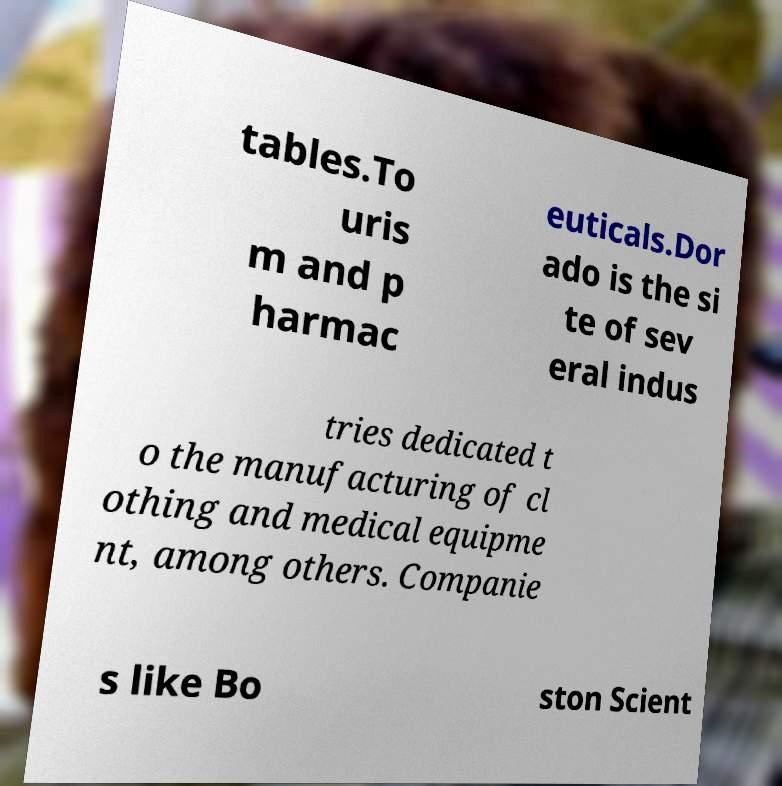There's text embedded in this image that I need extracted. Can you transcribe it verbatim? tables.To uris m and p harmac euticals.Dor ado is the si te of sev eral indus tries dedicated t o the manufacturing of cl othing and medical equipme nt, among others. Companie s like Bo ston Scient 